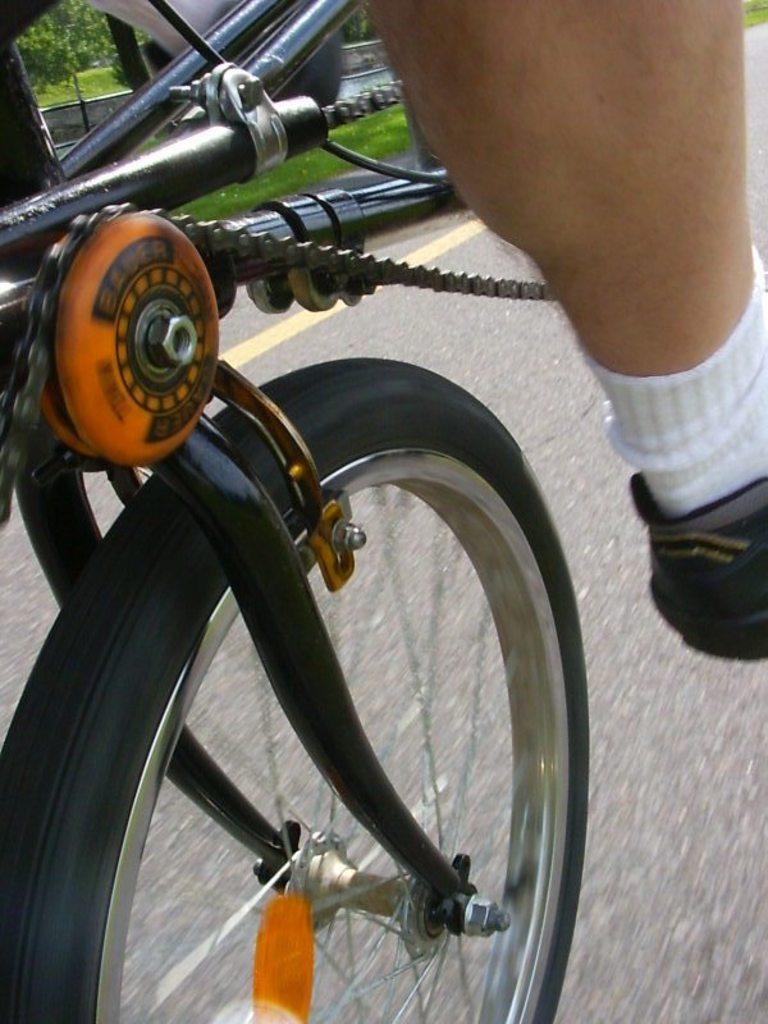Please provide a concise description of this image. In this image we can see wheel, rod, chain and person leg with shoes and socks. 